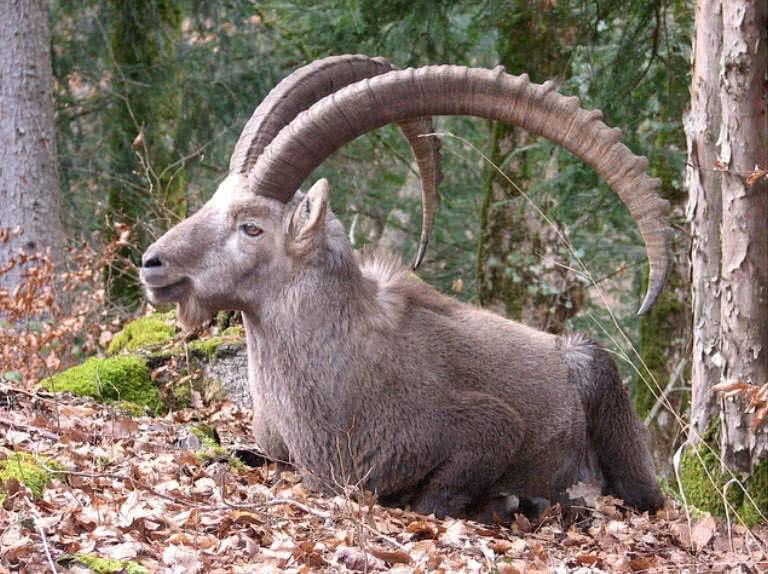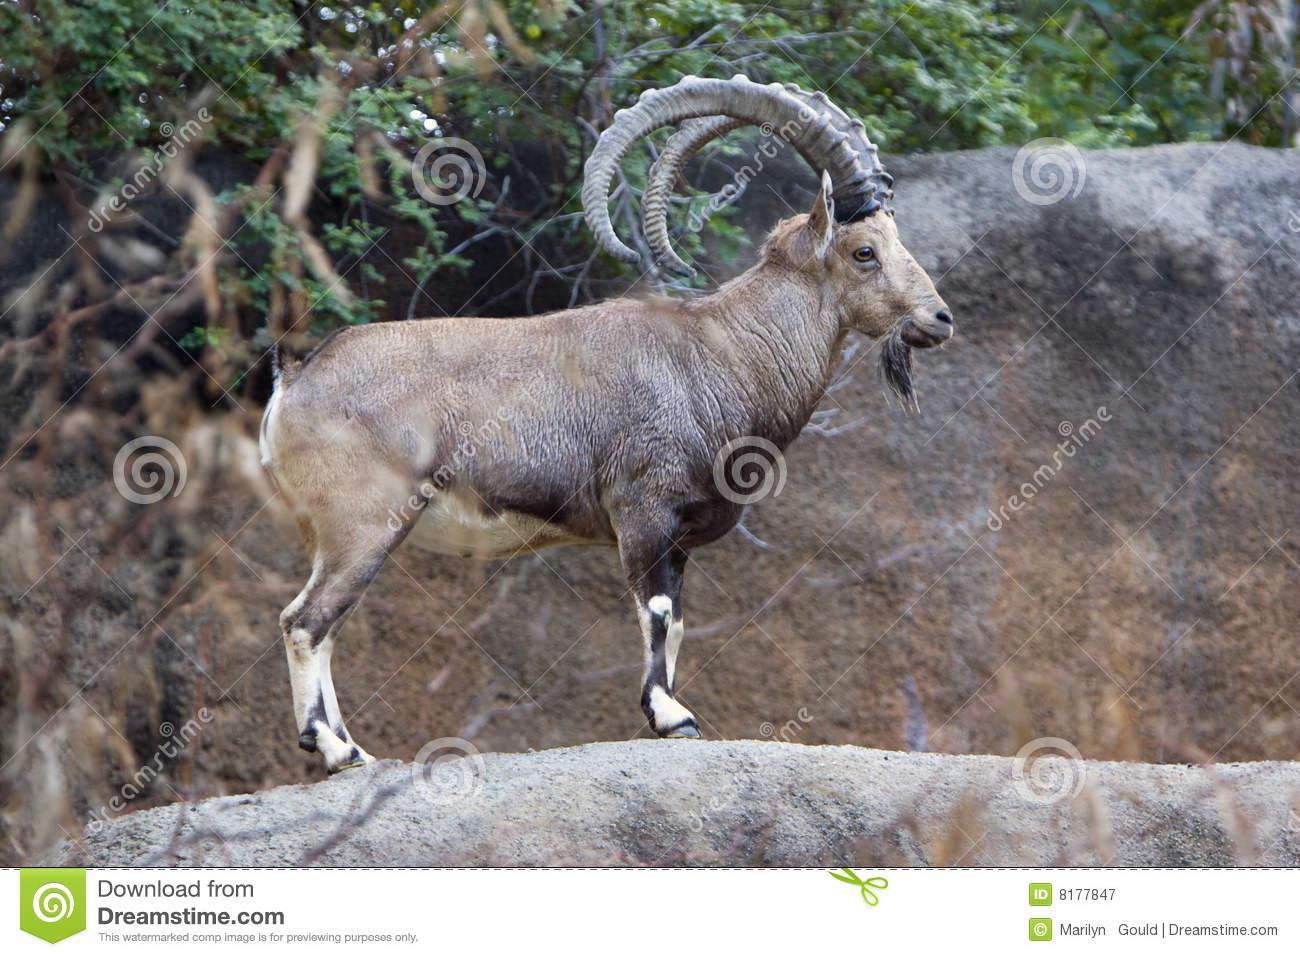The first image is the image on the left, the second image is the image on the right. For the images shown, is this caption "the animal on the right image is facing left" true? Answer yes or no. No. 